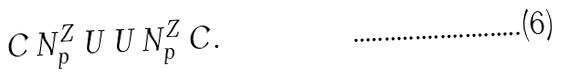Convert formula to latex. <formula><loc_0><loc_0><loc_500><loc_500>C \, N ^ { Z } _ { p } \, U \, U \, N ^ { Z } _ { p } \, C .</formula> 